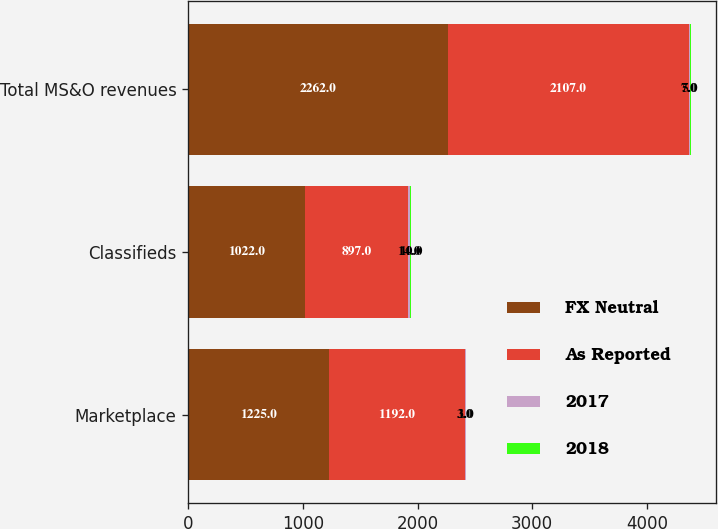Convert chart to OTSL. <chart><loc_0><loc_0><loc_500><loc_500><stacked_bar_chart><ecel><fcel>Marketplace<fcel>Classifieds<fcel>Total MS&O revenues<nl><fcel>FX Neutral<fcel>1225<fcel>1022<fcel>2262<nl><fcel>As Reported<fcel>1192<fcel>897<fcel>2107<nl><fcel>2017<fcel>3<fcel>14<fcel>7<nl><fcel>2018<fcel>1<fcel>10<fcel>5<nl></chart> 